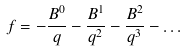<formula> <loc_0><loc_0><loc_500><loc_500>f = - \frac { B ^ { 0 } } { q } - \frac { B ^ { 1 } } { q ^ { 2 } } - \frac { B ^ { 2 } } { q ^ { 3 } } - \dots</formula> 